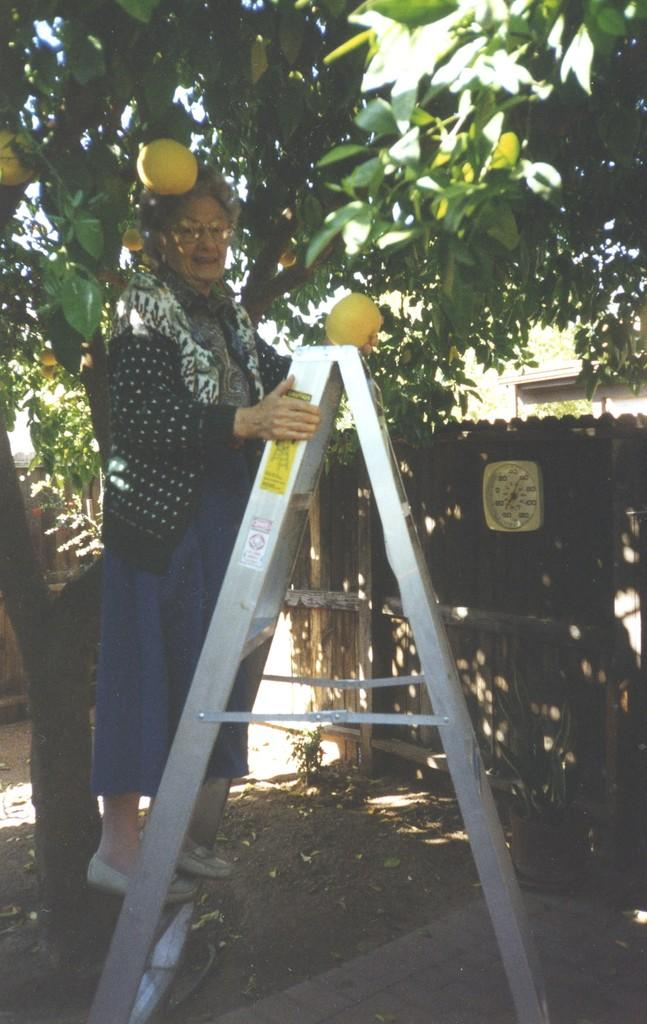What is the woman doing in the image? The woman is on a ladder in the image. What can be seen in the background of the image? There are trees in the image. What is present on the ground in the image? There are fruits in the image. What time-related object is visible in the image? There is a clock in the image. What type of structure can be seen in the image? There is a shed in the image. What type of bag is the slave carrying in the image? There is no bag or slave present in the image. The image features a woman on a ladder, trees, fruits, a clock, and a shed. 